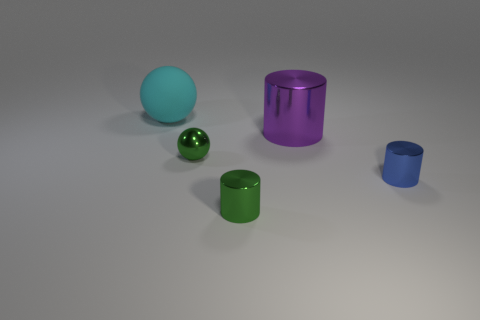Add 4 tiny cyan matte spheres. How many objects exist? 9 Subtract all spheres. How many objects are left? 3 Subtract 0 red spheres. How many objects are left? 5 Subtract all small green metallic blocks. Subtract all purple cylinders. How many objects are left? 4 Add 5 blue cylinders. How many blue cylinders are left? 6 Add 4 large purple things. How many large purple things exist? 5 